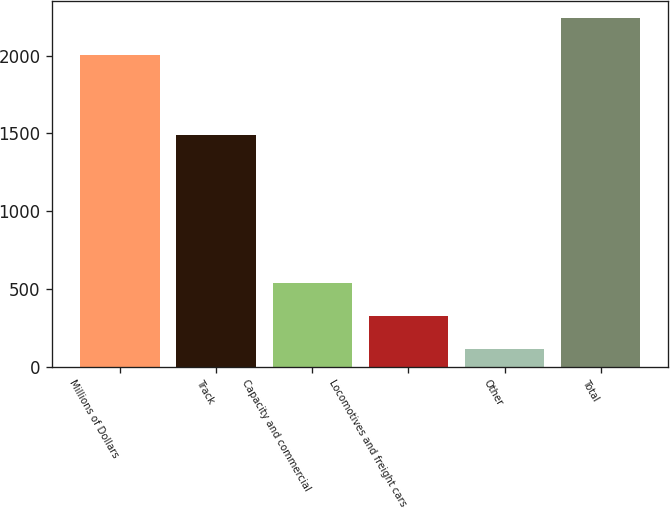Convert chart. <chart><loc_0><loc_0><loc_500><loc_500><bar_chart><fcel>Millions of Dollars<fcel>Track<fcel>Capacity and commercial<fcel>Locomotives and freight cars<fcel>Other<fcel>Total<nl><fcel>2006<fcel>1487<fcel>536.4<fcel>323.2<fcel>110<fcel>2242<nl></chart> 